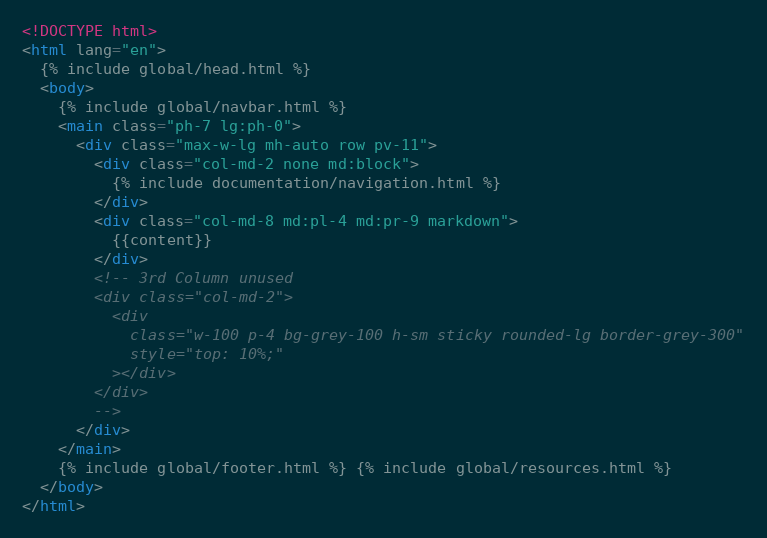Convert code to text. <code><loc_0><loc_0><loc_500><loc_500><_HTML_><!DOCTYPE html>
<html lang="en">
  {% include global/head.html %}
  <body>
    {% include global/navbar.html %}
    <main class="ph-7 lg:ph-0">
      <div class="max-w-lg mh-auto row pv-11">
        <div class="col-md-2 none md:block">
          {% include documentation/navigation.html %}
        </div>
        <div class="col-md-8 md:pl-4 md:pr-9 markdown">
          {{content}}
        </div>
        <!-- 3rd Column unused
        <div class="col-md-2">
          <div
            class="w-100 p-4 bg-grey-100 h-sm sticky rounded-lg border-grey-300"
            style="top: 10%;"
          ></div>
        </div>
        -->
      </div>
    </main>
    {% include global/footer.html %} {% include global/resources.html %}
  </body>
</html>
</code> 